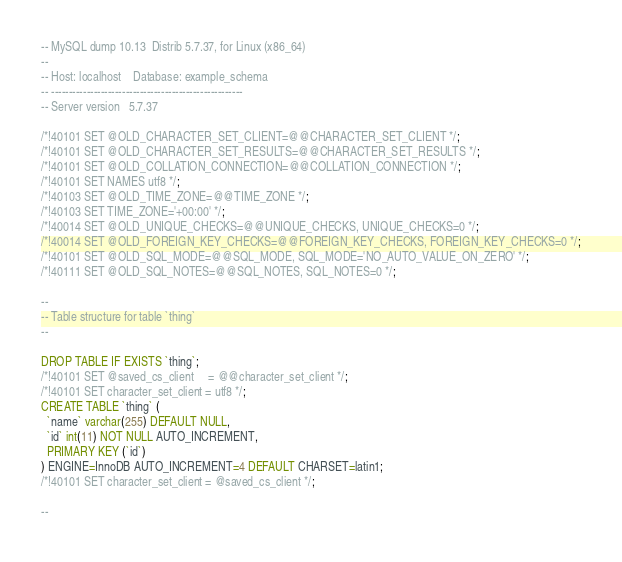Convert code to text. <code><loc_0><loc_0><loc_500><loc_500><_SQL_>-- MySQL dump 10.13  Distrib 5.7.37, for Linux (x86_64)
--
-- Host: localhost    Database: example_schema
-- ------------------------------------------------------
-- Server version	5.7.37

/*!40101 SET @OLD_CHARACTER_SET_CLIENT=@@CHARACTER_SET_CLIENT */;
/*!40101 SET @OLD_CHARACTER_SET_RESULTS=@@CHARACTER_SET_RESULTS */;
/*!40101 SET @OLD_COLLATION_CONNECTION=@@COLLATION_CONNECTION */;
/*!40101 SET NAMES utf8 */;
/*!40103 SET @OLD_TIME_ZONE=@@TIME_ZONE */;
/*!40103 SET TIME_ZONE='+00:00' */;
/*!40014 SET @OLD_UNIQUE_CHECKS=@@UNIQUE_CHECKS, UNIQUE_CHECKS=0 */;
/*!40014 SET @OLD_FOREIGN_KEY_CHECKS=@@FOREIGN_KEY_CHECKS, FOREIGN_KEY_CHECKS=0 */;
/*!40101 SET @OLD_SQL_MODE=@@SQL_MODE, SQL_MODE='NO_AUTO_VALUE_ON_ZERO' */;
/*!40111 SET @OLD_SQL_NOTES=@@SQL_NOTES, SQL_NOTES=0 */;

--
-- Table structure for table `thing`
--

DROP TABLE IF EXISTS `thing`;
/*!40101 SET @saved_cs_client     = @@character_set_client */;
/*!40101 SET character_set_client = utf8 */;
CREATE TABLE `thing` (
  `name` varchar(255) DEFAULT NULL,
  `id` int(11) NOT NULL AUTO_INCREMENT,
  PRIMARY KEY (`id`)
) ENGINE=InnoDB AUTO_INCREMENT=4 DEFAULT CHARSET=latin1;
/*!40101 SET character_set_client = @saved_cs_client */;

--</code> 